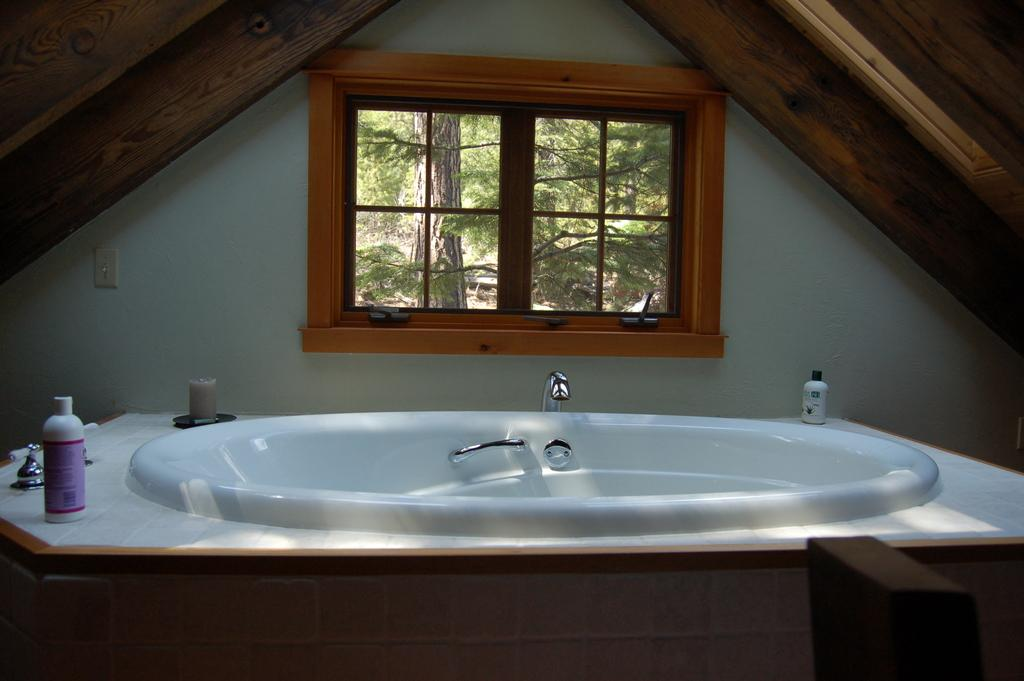What is located at the bottom of the image? There is a sink at the bottom of the image. What can be seen in the middle of the image? There is a window in the middle of the image. What is visible through the window? Trees are visible through the window. How many bears can be seen climbing the arch in the image? There are no bears or arches present in the image. 